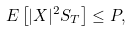Convert formula to latex. <formula><loc_0><loc_0><loc_500><loc_500>E \left [ | X | ^ { 2 } S _ { T } \right ] \leq P ,</formula> 